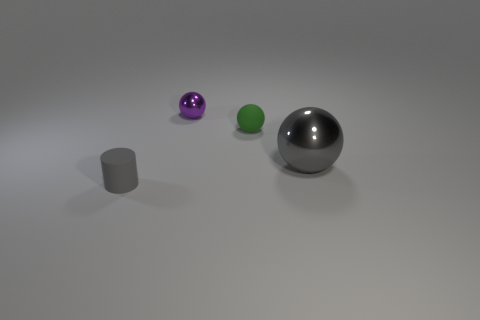Subtract all metallic spheres. How many spheres are left? 1 Subtract 1 balls. How many balls are left? 2 Add 4 balls. How many objects exist? 8 Subtract all balls. How many objects are left? 1 Subtract all blue balls. Subtract all red blocks. How many balls are left? 3 Subtract all tiny brown things. Subtract all matte things. How many objects are left? 2 Add 1 gray objects. How many gray objects are left? 3 Add 2 rubber balls. How many rubber balls exist? 3 Subtract 0 cyan balls. How many objects are left? 4 